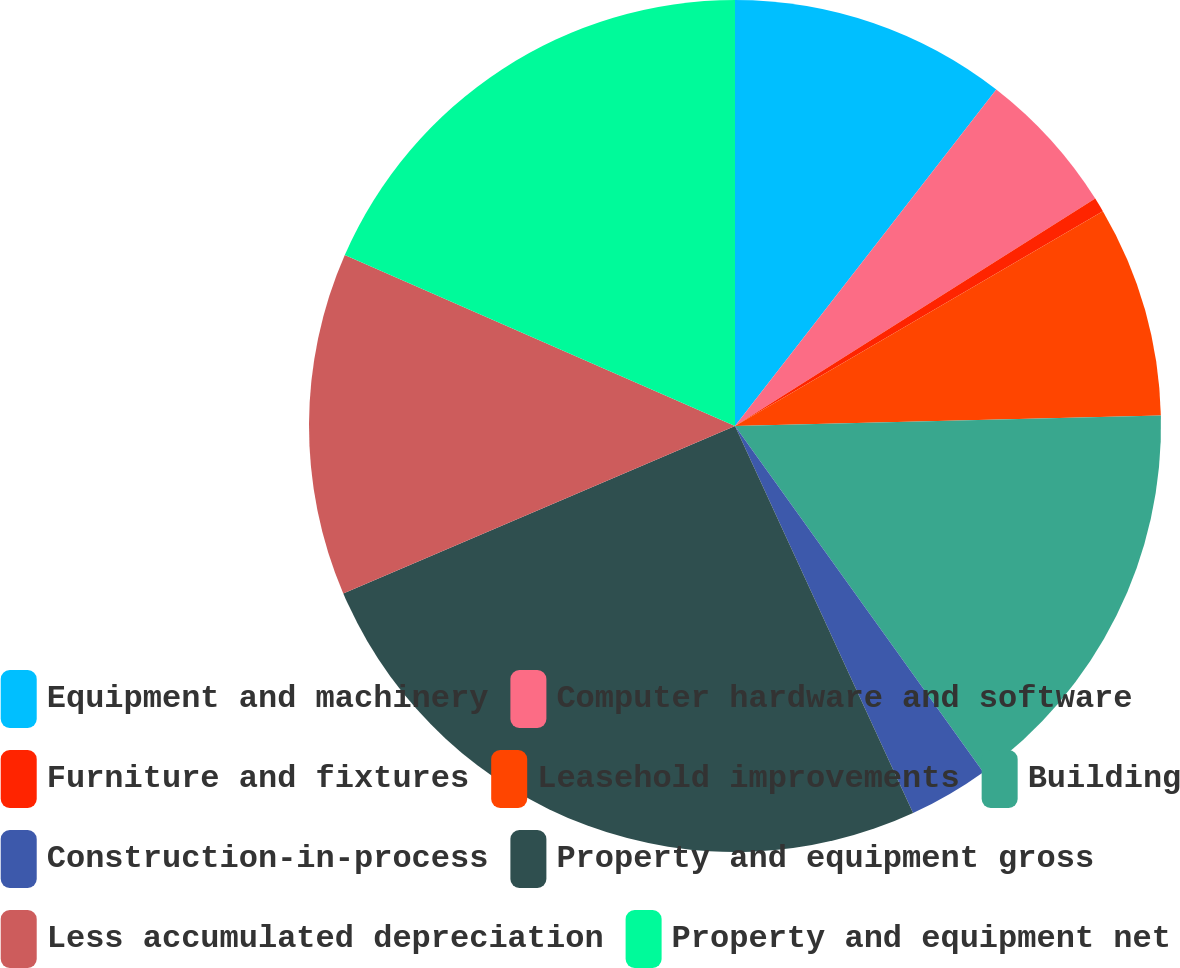<chart> <loc_0><loc_0><loc_500><loc_500><pie_chart><fcel>Equipment and machinery<fcel>Computer hardware and software<fcel>Furniture and fixtures<fcel>Leasehold improvements<fcel>Building<fcel>Construction-in-process<fcel>Property and equipment gross<fcel>Less accumulated depreciation<fcel>Property and equipment net<nl><fcel>10.51%<fcel>5.53%<fcel>0.55%<fcel>8.02%<fcel>15.49%<fcel>3.04%<fcel>25.44%<fcel>13.0%<fcel>18.43%<nl></chart> 